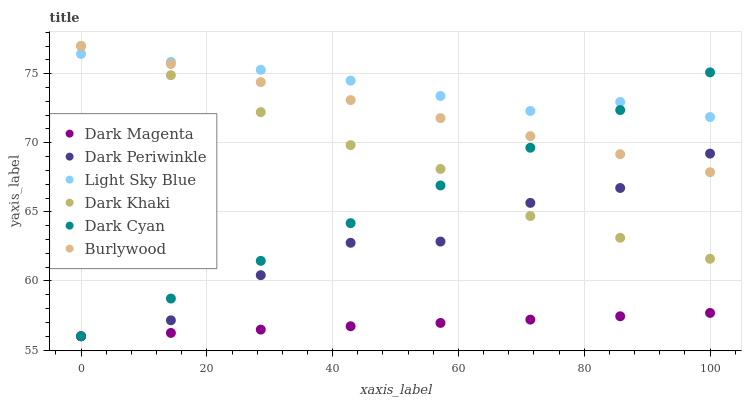Does Dark Magenta have the minimum area under the curve?
Answer yes or no. Yes. Does Light Sky Blue have the maximum area under the curve?
Answer yes or no. Yes. Does Burlywood have the minimum area under the curve?
Answer yes or no. No. Does Burlywood have the maximum area under the curve?
Answer yes or no. No. Is Burlywood the smoothest?
Answer yes or no. Yes. Is Dark Periwinkle the roughest?
Answer yes or no. Yes. Is Dark Khaki the smoothest?
Answer yes or no. No. Is Dark Khaki the roughest?
Answer yes or no. No. Does Dark Magenta have the lowest value?
Answer yes or no. Yes. Does Burlywood have the lowest value?
Answer yes or no. No. Does Dark Khaki have the highest value?
Answer yes or no. Yes. Does Light Sky Blue have the highest value?
Answer yes or no. No. Is Dark Magenta less than Dark Khaki?
Answer yes or no. Yes. Is Dark Khaki greater than Dark Magenta?
Answer yes or no. Yes. Does Burlywood intersect Dark Periwinkle?
Answer yes or no. Yes. Is Burlywood less than Dark Periwinkle?
Answer yes or no. No. Is Burlywood greater than Dark Periwinkle?
Answer yes or no. No. Does Dark Magenta intersect Dark Khaki?
Answer yes or no. No. 